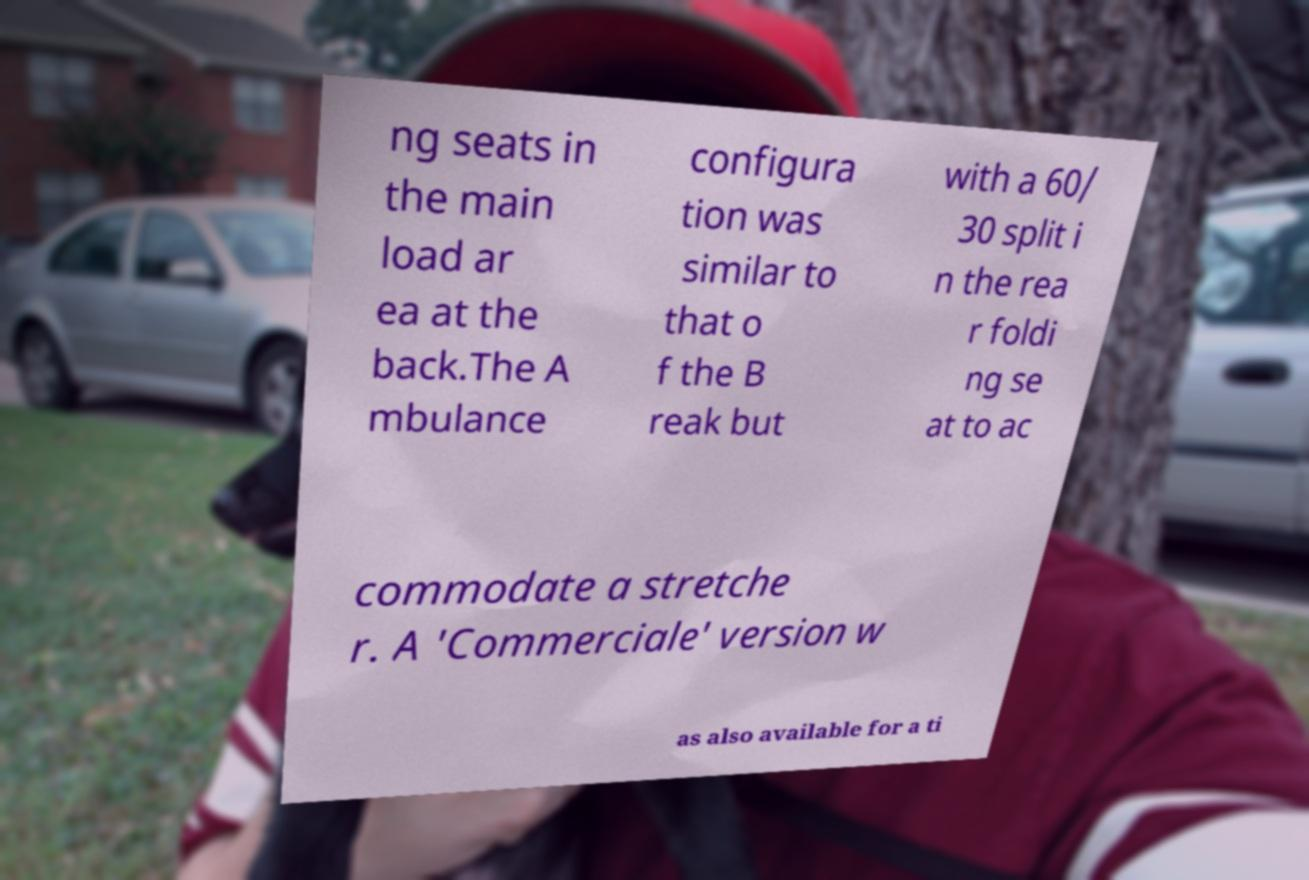Please identify and transcribe the text found in this image. ng seats in the main load ar ea at the back.The A mbulance configura tion was similar to that o f the B reak but with a 60/ 30 split i n the rea r foldi ng se at to ac commodate a stretche r. A 'Commerciale' version w as also available for a ti 